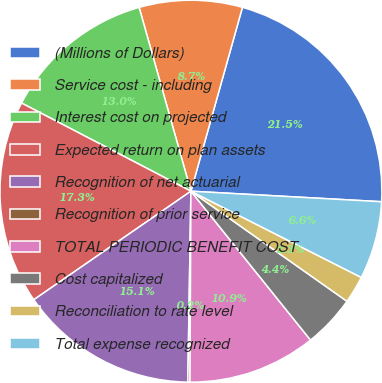Convert chart to OTSL. <chart><loc_0><loc_0><loc_500><loc_500><pie_chart><fcel>(Millions of Dollars)<fcel>Service cost - including<fcel>Interest cost on projected<fcel>Expected return on plan assets<fcel>Recognition of net actuarial<fcel>Recognition of prior service<fcel>TOTAL PERIODIC BENEFIT COST<fcel>Cost capitalized<fcel>Reconciliation to rate level<fcel>Total expense recognized<nl><fcel>21.53%<fcel>8.72%<fcel>12.99%<fcel>17.26%<fcel>15.12%<fcel>0.18%<fcel>10.85%<fcel>4.45%<fcel>2.32%<fcel>6.58%<nl></chart> 